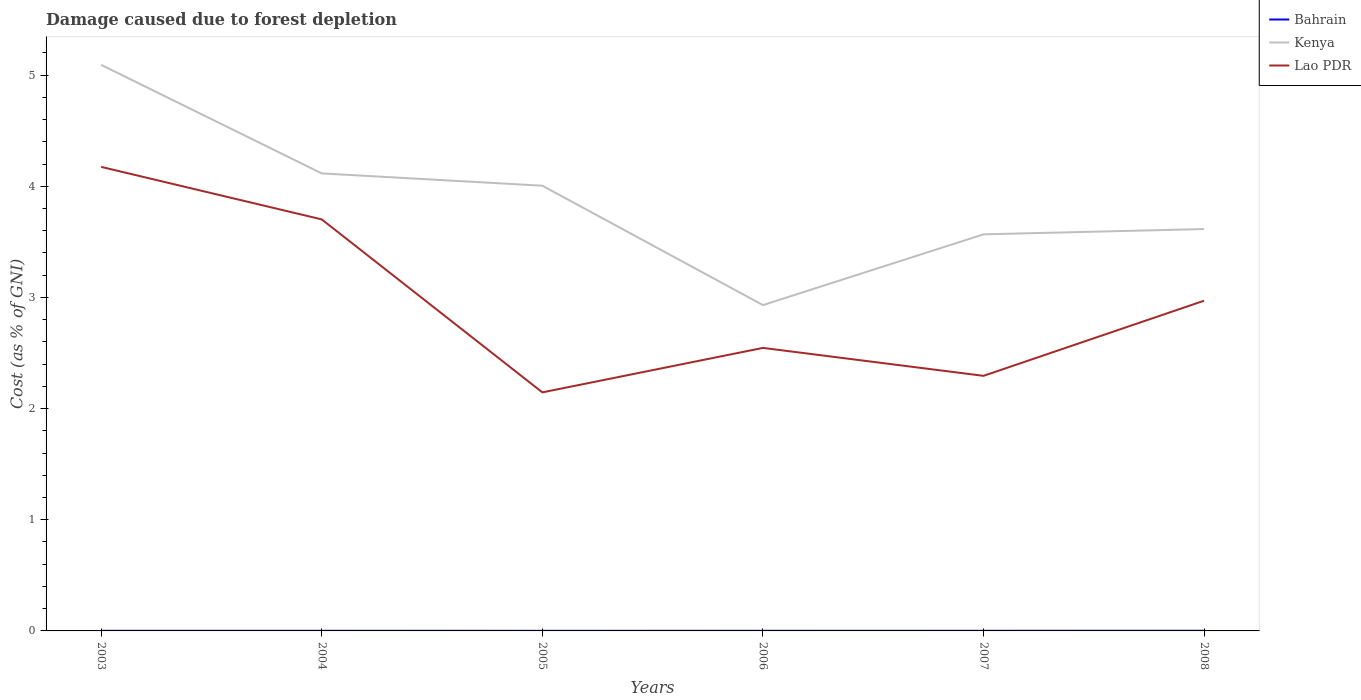Across all years, what is the maximum cost of damage caused due to forest depletion in Kenya?
Provide a succinct answer. 2.93. In which year was the cost of damage caused due to forest depletion in Kenya maximum?
Your response must be concise. 2006. What is the total cost of damage caused due to forest depletion in Bahrain in the graph?
Keep it short and to the point. -2.6496550479189994e-5. What is the difference between the highest and the second highest cost of damage caused due to forest depletion in Kenya?
Your response must be concise. 2.16. What is the difference between the highest and the lowest cost of damage caused due to forest depletion in Kenya?
Your response must be concise. 3. Is the cost of damage caused due to forest depletion in Bahrain strictly greater than the cost of damage caused due to forest depletion in Lao PDR over the years?
Offer a very short reply. Yes. How many lines are there?
Offer a terse response. 3. Are the values on the major ticks of Y-axis written in scientific E-notation?
Provide a short and direct response. No. Does the graph contain any zero values?
Make the answer very short. No. Where does the legend appear in the graph?
Your response must be concise. Top right. How are the legend labels stacked?
Make the answer very short. Vertical. What is the title of the graph?
Offer a very short reply. Damage caused due to forest depletion. Does "Caribbean small states" appear as one of the legend labels in the graph?
Provide a succinct answer. No. What is the label or title of the Y-axis?
Your answer should be compact. Cost (as % of GNI). What is the Cost (as % of GNI) in Bahrain in 2003?
Provide a succinct answer. 0. What is the Cost (as % of GNI) in Kenya in 2003?
Ensure brevity in your answer.  5.09. What is the Cost (as % of GNI) in Lao PDR in 2003?
Ensure brevity in your answer.  4.17. What is the Cost (as % of GNI) in Bahrain in 2004?
Ensure brevity in your answer.  0. What is the Cost (as % of GNI) in Kenya in 2004?
Offer a terse response. 4.12. What is the Cost (as % of GNI) of Lao PDR in 2004?
Provide a short and direct response. 3.7. What is the Cost (as % of GNI) of Bahrain in 2005?
Give a very brief answer. 0. What is the Cost (as % of GNI) of Kenya in 2005?
Offer a terse response. 4.01. What is the Cost (as % of GNI) in Lao PDR in 2005?
Give a very brief answer. 2.15. What is the Cost (as % of GNI) in Bahrain in 2006?
Provide a short and direct response. 0. What is the Cost (as % of GNI) of Kenya in 2006?
Your answer should be compact. 2.93. What is the Cost (as % of GNI) of Lao PDR in 2006?
Make the answer very short. 2.55. What is the Cost (as % of GNI) of Bahrain in 2007?
Provide a short and direct response. 0. What is the Cost (as % of GNI) in Kenya in 2007?
Your response must be concise. 3.57. What is the Cost (as % of GNI) in Lao PDR in 2007?
Offer a terse response. 2.29. What is the Cost (as % of GNI) in Bahrain in 2008?
Provide a succinct answer. 0. What is the Cost (as % of GNI) of Kenya in 2008?
Your response must be concise. 3.62. What is the Cost (as % of GNI) of Lao PDR in 2008?
Make the answer very short. 2.97. Across all years, what is the maximum Cost (as % of GNI) in Bahrain?
Make the answer very short. 0. Across all years, what is the maximum Cost (as % of GNI) in Kenya?
Give a very brief answer. 5.09. Across all years, what is the maximum Cost (as % of GNI) in Lao PDR?
Give a very brief answer. 4.17. Across all years, what is the minimum Cost (as % of GNI) of Bahrain?
Ensure brevity in your answer.  0. Across all years, what is the minimum Cost (as % of GNI) of Kenya?
Keep it short and to the point. 2.93. Across all years, what is the minimum Cost (as % of GNI) in Lao PDR?
Make the answer very short. 2.15. What is the total Cost (as % of GNI) in Bahrain in the graph?
Offer a very short reply. 0.01. What is the total Cost (as % of GNI) in Kenya in the graph?
Your answer should be compact. 23.33. What is the total Cost (as % of GNI) of Lao PDR in the graph?
Your response must be concise. 17.83. What is the difference between the Cost (as % of GNI) in Bahrain in 2003 and that in 2004?
Your answer should be very brief. 0. What is the difference between the Cost (as % of GNI) in Kenya in 2003 and that in 2004?
Your response must be concise. 0.98. What is the difference between the Cost (as % of GNI) of Lao PDR in 2003 and that in 2004?
Provide a succinct answer. 0.47. What is the difference between the Cost (as % of GNI) in Kenya in 2003 and that in 2005?
Ensure brevity in your answer.  1.09. What is the difference between the Cost (as % of GNI) of Lao PDR in 2003 and that in 2005?
Offer a terse response. 2.03. What is the difference between the Cost (as % of GNI) of Bahrain in 2003 and that in 2006?
Provide a succinct answer. 0. What is the difference between the Cost (as % of GNI) in Kenya in 2003 and that in 2006?
Your answer should be very brief. 2.16. What is the difference between the Cost (as % of GNI) of Lao PDR in 2003 and that in 2006?
Ensure brevity in your answer.  1.63. What is the difference between the Cost (as % of GNI) in Bahrain in 2003 and that in 2007?
Keep it short and to the point. -0. What is the difference between the Cost (as % of GNI) in Kenya in 2003 and that in 2007?
Give a very brief answer. 1.52. What is the difference between the Cost (as % of GNI) in Lao PDR in 2003 and that in 2007?
Offer a very short reply. 1.88. What is the difference between the Cost (as % of GNI) of Bahrain in 2003 and that in 2008?
Provide a succinct answer. -0. What is the difference between the Cost (as % of GNI) of Kenya in 2003 and that in 2008?
Your response must be concise. 1.48. What is the difference between the Cost (as % of GNI) of Lao PDR in 2003 and that in 2008?
Make the answer very short. 1.2. What is the difference between the Cost (as % of GNI) of Bahrain in 2004 and that in 2005?
Keep it short and to the point. 0. What is the difference between the Cost (as % of GNI) of Kenya in 2004 and that in 2005?
Offer a very short reply. 0.11. What is the difference between the Cost (as % of GNI) of Lao PDR in 2004 and that in 2005?
Ensure brevity in your answer.  1.56. What is the difference between the Cost (as % of GNI) of Kenya in 2004 and that in 2006?
Give a very brief answer. 1.18. What is the difference between the Cost (as % of GNI) in Lao PDR in 2004 and that in 2006?
Your answer should be compact. 1.16. What is the difference between the Cost (as % of GNI) of Bahrain in 2004 and that in 2007?
Your answer should be compact. -0. What is the difference between the Cost (as % of GNI) in Kenya in 2004 and that in 2007?
Keep it short and to the point. 0.55. What is the difference between the Cost (as % of GNI) in Lao PDR in 2004 and that in 2007?
Your response must be concise. 1.41. What is the difference between the Cost (as % of GNI) in Bahrain in 2004 and that in 2008?
Provide a short and direct response. -0. What is the difference between the Cost (as % of GNI) of Kenya in 2004 and that in 2008?
Your answer should be very brief. 0.5. What is the difference between the Cost (as % of GNI) in Lao PDR in 2004 and that in 2008?
Make the answer very short. 0.73. What is the difference between the Cost (as % of GNI) of Bahrain in 2005 and that in 2006?
Give a very brief answer. -0. What is the difference between the Cost (as % of GNI) of Kenya in 2005 and that in 2006?
Your answer should be very brief. 1.07. What is the difference between the Cost (as % of GNI) in Bahrain in 2005 and that in 2007?
Keep it short and to the point. -0. What is the difference between the Cost (as % of GNI) in Kenya in 2005 and that in 2007?
Your answer should be very brief. 0.44. What is the difference between the Cost (as % of GNI) in Lao PDR in 2005 and that in 2007?
Ensure brevity in your answer.  -0.15. What is the difference between the Cost (as % of GNI) in Bahrain in 2005 and that in 2008?
Give a very brief answer. -0. What is the difference between the Cost (as % of GNI) of Kenya in 2005 and that in 2008?
Provide a succinct answer. 0.39. What is the difference between the Cost (as % of GNI) in Lao PDR in 2005 and that in 2008?
Your response must be concise. -0.82. What is the difference between the Cost (as % of GNI) in Bahrain in 2006 and that in 2007?
Your response must be concise. -0. What is the difference between the Cost (as % of GNI) of Kenya in 2006 and that in 2007?
Your answer should be very brief. -0.64. What is the difference between the Cost (as % of GNI) in Lao PDR in 2006 and that in 2007?
Ensure brevity in your answer.  0.25. What is the difference between the Cost (as % of GNI) of Bahrain in 2006 and that in 2008?
Keep it short and to the point. -0. What is the difference between the Cost (as % of GNI) of Kenya in 2006 and that in 2008?
Offer a terse response. -0.68. What is the difference between the Cost (as % of GNI) in Lao PDR in 2006 and that in 2008?
Make the answer very short. -0.42. What is the difference between the Cost (as % of GNI) in Bahrain in 2007 and that in 2008?
Give a very brief answer. -0. What is the difference between the Cost (as % of GNI) in Kenya in 2007 and that in 2008?
Your answer should be very brief. -0.05. What is the difference between the Cost (as % of GNI) of Lao PDR in 2007 and that in 2008?
Provide a short and direct response. -0.68. What is the difference between the Cost (as % of GNI) of Bahrain in 2003 and the Cost (as % of GNI) of Kenya in 2004?
Offer a very short reply. -4.11. What is the difference between the Cost (as % of GNI) in Bahrain in 2003 and the Cost (as % of GNI) in Lao PDR in 2004?
Your response must be concise. -3.7. What is the difference between the Cost (as % of GNI) of Kenya in 2003 and the Cost (as % of GNI) of Lao PDR in 2004?
Keep it short and to the point. 1.39. What is the difference between the Cost (as % of GNI) in Bahrain in 2003 and the Cost (as % of GNI) in Kenya in 2005?
Provide a short and direct response. -4. What is the difference between the Cost (as % of GNI) in Bahrain in 2003 and the Cost (as % of GNI) in Lao PDR in 2005?
Your answer should be very brief. -2.15. What is the difference between the Cost (as % of GNI) in Kenya in 2003 and the Cost (as % of GNI) in Lao PDR in 2005?
Your answer should be compact. 2.95. What is the difference between the Cost (as % of GNI) of Bahrain in 2003 and the Cost (as % of GNI) of Kenya in 2006?
Offer a terse response. -2.93. What is the difference between the Cost (as % of GNI) of Bahrain in 2003 and the Cost (as % of GNI) of Lao PDR in 2006?
Make the answer very short. -2.54. What is the difference between the Cost (as % of GNI) of Kenya in 2003 and the Cost (as % of GNI) of Lao PDR in 2006?
Provide a succinct answer. 2.55. What is the difference between the Cost (as % of GNI) of Bahrain in 2003 and the Cost (as % of GNI) of Kenya in 2007?
Keep it short and to the point. -3.57. What is the difference between the Cost (as % of GNI) of Bahrain in 2003 and the Cost (as % of GNI) of Lao PDR in 2007?
Provide a succinct answer. -2.29. What is the difference between the Cost (as % of GNI) of Kenya in 2003 and the Cost (as % of GNI) of Lao PDR in 2007?
Offer a very short reply. 2.8. What is the difference between the Cost (as % of GNI) of Bahrain in 2003 and the Cost (as % of GNI) of Kenya in 2008?
Keep it short and to the point. -3.61. What is the difference between the Cost (as % of GNI) in Bahrain in 2003 and the Cost (as % of GNI) in Lao PDR in 2008?
Your answer should be very brief. -2.97. What is the difference between the Cost (as % of GNI) of Kenya in 2003 and the Cost (as % of GNI) of Lao PDR in 2008?
Your answer should be very brief. 2.12. What is the difference between the Cost (as % of GNI) of Bahrain in 2004 and the Cost (as % of GNI) of Kenya in 2005?
Your response must be concise. -4. What is the difference between the Cost (as % of GNI) in Bahrain in 2004 and the Cost (as % of GNI) in Lao PDR in 2005?
Your answer should be very brief. -2.15. What is the difference between the Cost (as % of GNI) in Kenya in 2004 and the Cost (as % of GNI) in Lao PDR in 2005?
Make the answer very short. 1.97. What is the difference between the Cost (as % of GNI) of Bahrain in 2004 and the Cost (as % of GNI) of Kenya in 2006?
Your answer should be very brief. -2.93. What is the difference between the Cost (as % of GNI) in Bahrain in 2004 and the Cost (as % of GNI) in Lao PDR in 2006?
Give a very brief answer. -2.54. What is the difference between the Cost (as % of GNI) in Kenya in 2004 and the Cost (as % of GNI) in Lao PDR in 2006?
Your response must be concise. 1.57. What is the difference between the Cost (as % of GNI) in Bahrain in 2004 and the Cost (as % of GNI) in Kenya in 2007?
Keep it short and to the point. -3.57. What is the difference between the Cost (as % of GNI) in Bahrain in 2004 and the Cost (as % of GNI) in Lao PDR in 2007?
Ensure brevity in your answer.  -2.29. What is the difference between the Cost (as % of GNI) in Kenya in 2004 and the Cost (as % of GNI) in Lao PDR in 2007?
Provide a succinct answer. 1.82. What is the difference between the Cost (as % of GNI) in Bahrain in 2004 and the Cost (as % of GNI) in Kenya in 2008?
Give a very brief answer. -3.61. What is the difference between the Cost (as % of GNI) in Bahrain in 2004 and the Cost (as % of GNI) in Lao PDR in 2008?
Ensure brevity in your answer.  -2.97. What is the difference between the Cost (as % of GNI) of Kenya in 2004 and the Cost (as % of GNI) of Lao PDR in 2008?
Provide a short and direct response. 1.15. What is the difference between the Cost (as % of GNI) in Bahrain in 2005 and the Cost (as % of GNI) in Kenya in 2006?
Your response must be concise. -2.93. What is the difference between the Cost (as % of GNI) in Bahrain in 2005 and the Cost (as % of GNI) in Lao PDR in 2006?
Keep it short and to the point. -2.55. What is the difference between the Cost (as % of GNI) in Kenya in 2005 and the Cost (as % of GNI) in Lao PDR in 2006?
Make the answer very short. 1.46. What is the difference between the Cost (as % of GNI) in Bahrain in 2005 and the Cost (as % of GNI) in Kenya in 2007?
Give a very brief answer. -3.57. What is the difference between the Cost (as % of GNI) of Bahrain in 2005 and the Cost (as % of GNI) of Lao PDR in 2007?
Your answer should be very brief. -2.29. What is the difference between the Cost (as % of GNI) in Kenya in 2005 and the Cost (as % of GNI) in Lao PDR in 2007?
Your answer should be compact. 1.71. What is the difference between the Cost (as % of GNI) of Bahrain in 2005 and the Cost (as % of GNI) of Kenya in 2008?
Provide a short and direct response. -3.61. What is the difference between the Cost (as % of GNI) of Bahrain in 2005 and the Cost (as % of GNI) of Lao PDR in 2008?
Offer a very short reply. -2.97. What is the difference between the Cost (as % of GNI) of Kenya in 2005 and the Cost (as % of GNI) of Lao PDR in 2008?
Your answer should be very brief. 1.03. What is the difference between the Cost (as % of GNI) of Bahrain in 2006 and the Cost (as % of GNI) of Kenya in 2007?
Offer a very short reply. -3.57. What is the difference between the Cost (as % of GNI) in Bahrain in 2006 and the Cost (as % of GNI) in Lao PDR in 2007?
Your response must be concise. -2.29. What is the difference between the Cost (as % of GNI) of Kenya in 2006 and the Cost (as % of GNI) of Lao PDR in 2007?
Ensure brevity in your answer.  0.64. What is the difference between the Cost (as % of GNI) of Bahrain in 2006 and the Cost (as % of GNI) of Kenya in 2008?
Provide a succinct answer. -3.61. What is the difference between the Cost (as % of GNI) in Bahrain in 2006 and the Cost (as % of GNI) in Lao PDR in 2008?
Offer a terse response. -2.97. What is the difference between the Cost (as % of GNI) of Kenya in 2006 and the Cost (as % of GNI) of Lao PDR in 2008?
Offer a very short reply. -0.04. What is the difference between the Cost (as % of GNI) of Bahrain in 2007 and the Cost (as % of GNI) of Kenya in 2008?
Provide a succinct answer. -3.61. What is the difference between the Cost (as % of GNI) of Bahrain in 2007 and the Cost (as % of GNI) of Lao PDR in 2008?
Give a very brief answer. -2.97. What is the difference between the Cost (as % of GNI) of Kenya in 2007 and the Cost (as % of GNI) of Lao PDR in 2008?
Ensure brevity in your answer.  0.6. What is the average Cost (as % of GNI) in Bahrain per year?
Your answer should be compact. 0. What is the average Cost (as % of GNI) in Kenya per year?
Your response must be concise. 3.89. What is the average Cost (as % of GNI) in Lao PDR per year?
Provide a succinct answer. 2.97. In the year 2003, what is the difference between the Cost (as % of GNI) of Bahrain and Cost (as % of GNI) of Kenya?
Make the answer very short. -5.09. In the year 2003, what is the difference between the Cost (as % of GNI) of Bahrain and Cost (as % of GNI) of Lao PDR?
Provide a short and direct response. -4.17. In the year 2003, what is the difference between the Cost (as % of GNI) in Kenya and Cost (as % of GNI) in Lao PDR?
Give a very brief answer. 0.92. In the year 2004, what is the difference between the Cost (as % of GNI) in Bahrain and Cost (as % of GNI) in Kenya?
Ensure brevity in your answer.  -4.11. In the year 2004, what is the difference between the Cost (as % of GNI) of Bahrain and Cost (as % of GNI) of Lao PDR?
Offer a very short reply. -3.7. In the year 2004, what is the difference between the Cost (as % of GNI) in Kenya and Cost (as % of GNI) in Lao PDR?
Provide a short and direct response. 0.41. In the year 2005, what is the difference between the Cost (as % of GNI) of Bahrain and Cost (as % of GNI) of Kenya?
Offer a terse response. -4. In the year 2005, what is the difference between the Cost (as % of GNI) in Bahrain and Cost (as % of GNI) in Lao PDR?
Offer a very short reply. -2.15. In the year 2005, what is the difference between the Cost (as % of GNI) in Kenya and Cost (as % of GNI) in Lao PDR?
Your response must be concise. 1.86. In the year 2006, what is the difference between the Cost (as % of GNI) of Bahrain and Cost (as % of GNI) of Kenya?
Provide a short and direct response. -2.93. In the year 2006, what is the difference between the Cost (as % of GNI) of Bahrain and Cost (as % of GNI) of Lao PDR?
Your answer should be compact. -2.55. In the year 2006, what is the difference between the Cost (as % of GNI) in Kenya and Cost (as % of GNI) in Lao PDR?
Offer a very short reply. 0.39. In the year 2007, what is the difference between the Cost (as % of GNI) of Bahrain and Cost (as % of GNI) of Kenya?
Your response must be concise. -3.57. In the year 2007, what is the difference between the Cost (as % of GNI) of Bahrain and Cost (as % of GNI) of Lao PDR?
Your response must be concise. -2.29. In the year 2007, what is the difference between the Cost (as % of GNI) in Kenya and Cost (as % of GNI) in Lao PDR?
Your answer should be very brief. 1.27. In the year 2008, what is the difference between the Cost (as % of GNI) of Bahrain and Cost (as % of GNI) of Kenya?
Ensure brevity in your answer.  -3.61. In the year 2008, what is the difference between the Cost (as % of GNI) in Bahrain and Cost (as % of GNI) in Lao PDR?
Ensure brevity in your answer.  -2.97. In the year 2008, what is the difference between the Cost (as % of GNI) in Kenya and Cost (as % of GNI) in Lao PDR?
Give a very brief answer. 0.64. What is the ratio of the Cost (as % of GNI) in Kenya in 2003 to that in 2004?
Keep it short and to the point. 1.24. What is the ratio of the Cost (as % of GNI) of Lao PDR in 2003 to that in 2004?
Offer a terse response. 1.13. What is the ratio of the Cost (as % of GNI) of Bahrain in 2003 to that in 2005?
Keep it short and to the point. 1.28. What is the ratio of the Cost (as % of GNI) of Kenya in 2003 to that in 2005?
Keep it short and to the point. 1.27. What is the ratio of the Cost (as % of GNI) in Lao PDR in 2003 to that in 2005?
Your answer should be compact. 1.95. What is the ratio of the Cost (as % of GNI) of Bahrain in 2003 to that in 2006?
Your answer should be compact. 1.15. What is the ratio of the Cost (as % of GNI) of Kenya in 2003 to that in 2006?
Provide a succinct answer. 1.74. What is the ratio of the Cost (as % of GNI) of Lao PDR in 2003 to that in 2006?
Keep it short and to the point. 1.64. What is the ratio of the Cost (as % of GNI) of Bahrain in 2003 to that in 2007?
Give a very brief answer. 0.98. What is the ratio of the Cost (as % of GNI) of Kenya in 2003 to that in 2007?
Give a very brief answer. 1.43. What is the ratio of the Cost (as % of GNI) of Lao PDR in 2003 to that in 2007?
Offer a very short reply. 1.82. What is the ratio of the Cost (as % of GNI) of Bahrain in 2003 to that in 2008?
Your answer should be compact. 0.81. What is the ratio of the Cost (as % of GNI) of Kenya in 2003 to that in 2008?
Ensure brevity in your answer.  1.41. What is the ratio of the Cost (as % of GNI) of Lao PDR in 2003 to that in 2008?
Offer a very short reply. 1.41. What is the ratio of the Cost (as % of GNI) of Bahrain in 2004 to that in 2005?
Keep it short and to the point. 1.22. What is the ratio of the Cost (as % of GNI) in Kenya in 2004 to that in 2005?
Provide a succinct answer. 1.03. What is the ratio of the Cost (as % of GNI) in Lao PDR in 2004 to that in 2005?
Your answer should be very brief. 1.73. What is the ratio of the Cost (as % of GNI) of Bahrain in 2004 to that in 2006?
Make the answer very short. 1.1. What is the ratio of the Cost (as % of GNI) of Kenya in 2004 to that in 2006?
Provide a succinct answer. 1.4. What is the ratio of the Cost (as % of GNI) of Lao PDR in 2004 to that in 2006?
Your answer should be very brief. 1.45. What is the ratio of the Cost (as % of GNI) of Bahrain in 2004 to that in 2007?
Make the answer very short. 0.93. What is the ratio of the Cost (as % of GNI) in Kenya in 2004 to that in 2007?
Your answer should be very brief. 1.15. What is the ratio of the Cost (as % of GNI) in Lao PDR in 2004 to that in 2007?
Offer a very short reply. 1.61. What is the ratio of the Cost (as % of GNI) in Bahrain in 2004 to that in 2008?
Give a very brief answer. 0.78. What is the ratio of the Cost (as % of GNI) in Kenya in 2004 to that in 2008?
Ensure brevity in your answer.  1.14. What is the ratio of the Cost (as % of GNI) of Lao PDR in 2004 to that in 2008?
Ensure brevity in your answer.  1.25. What is the ratio of the Cost (as % of GNI) in Bahrain in 2005 to that in 2006?
Provide a short and direct response. 0.9. What is the ratio of the Cost (as % of GNI) of Kenya in 2005 to that in 2006?
Provide a succinct answer. 1.37. What is the ratio of the Cost (as % of GNI) of Lao PDR in 2005 to that in 2006?
Your answer should be very brief. 0.84. What is the ratio of the Cost (as % of GNI) in Bahrain in 2005 to that in 2007?
Provide a succinct answer. 0.76. What is the ratio of the Cost (as % of GNI) in Kenya in 2005 to that in 2007?
Your answer should be very brief. 1.12. What is the ratio of the Cost (as % of GNI) of Lao PDR in 2005 to that in 2007?
Provide a short and direct response. 0.94. What is the ratio of the Cost (as % of GNI) in Bahrain in 2005 to that in 2008?
Your response must be concise. 0.64. What is the ratio of the Cost (as % of GNI) in Kenya in 2005 to that in 2008?
Give a very brief answer. 1.11. What is the ratio of the Cost (as % of GNI) of Lao PDR in 2005 to that in 2008?
Your response must be concise. 0.72. What is the ratio of the Cost (as % of GNI) in Bahrain in 2006 to that in 2007?
Ensure brevity in your answer.  0.85. What is the ratio of the Cost (as % of GNI) in Kenya in 2006 to that in 2007?
Make the answer very short. 0.82. What is the ratio of the Cost (as % of GNI) of Lao PDR in 2006 to that in 2007?
Provide a succinct answer. 1.11. What is the ratio of the Cost (as % of GNI) in Bahrain in 2006 to that in 2008?
Your answer should be compact. 0.71. What is the ratio of the Cost (as % of GNI) of Kenya in 2006 to that in 2008?
Provide a succinct answer. 0.81. What is the ratio of the Cost (as % of GNI) of Lao PDR in 2006 to that in 2008?
Your response must be concise. 0.86. What is the ratio of the Cost (as % of GNI) in Bahrain in 2007 to that in 2008?
Provide a succinct answer. 0.83. What is the ratio of the Cost (as % of GNI) in Kenya in 2007 to that in 2008?
Ensure brevity in your answer.  0.99. What is the ratio of the Cost (as % of GNI) of Lao PDR in 2007 to that in 2008?
Give a very brief answer. 0.77. What is the difference between the highest and the second highest Cost (as % of GNI) in Bahrain?
Your answer should be very brief. 0. What is the difference between the highest and the second highest Cost (as % of GNI) of Kenya?
Offer a very short reply. 0.98. What is the difference between the highest and the second highest Cost (as % of GNI) in Lao PDR?
Your answer should be very brief. 0.47. What is the difference between the highest and the lowest Cost (as % of GNI) of Bahrain?
Give a very brief answer. 0. What is the difference between the highest and the lowest Cost (as % of GNI) of Kenya?
Your response must be concise. 2.16. What is the difference between the highest and the lowest Cost (as % of GNI) of Lao PDR?
Offer a terse response. 2.03. 